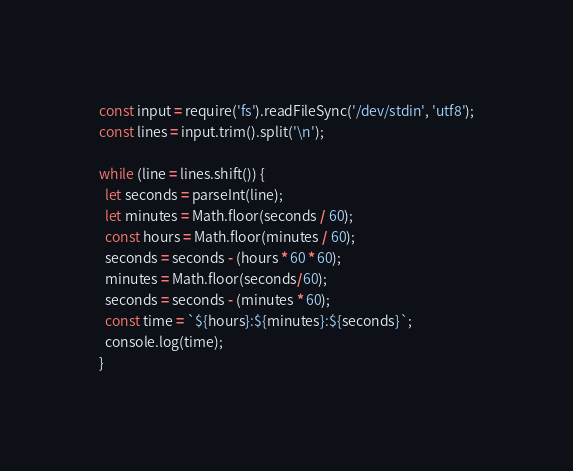<code> <loc_0><loc_0><loc_500><loc_500><_JavaScript_>const input = require('fs').readFileSync('/dev/stdin', 'utf8');
const lines = input.trim().split('\n');

while (line = lines.shift()) {
  let seconds = parseInt(line);
  let minutes = Math.floor(seconds / 60);
  const hours = Math.floor(minutes / 60);
  seconds = seconds - (hours * 60 * 60);
  minutes = Math.floor(seconds/60);
  seconds = seconds - (minutes * 60);
  const time = `${hours}:${minutes}:${seconds}`;
  console.log(time);
} 
</code> 